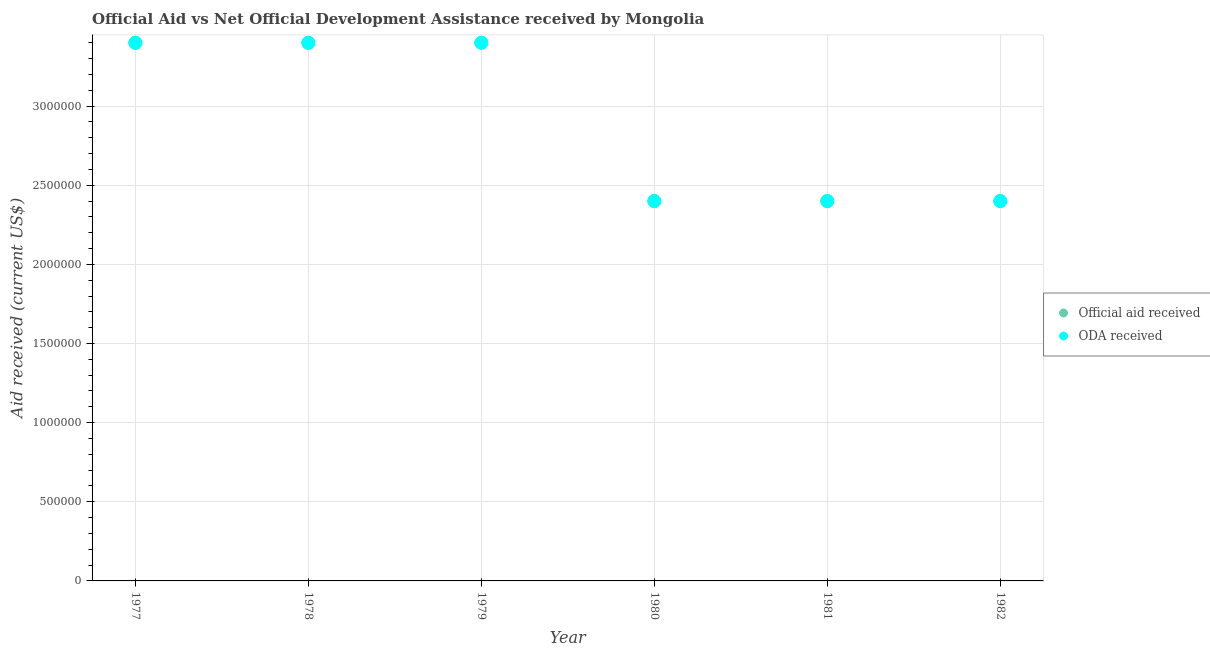How many different coloured dotlines are there?
Offer a very short reply. 2. What is the oda received in 1978?
Provide a succinct answer. 3.40e+06. Across all years, what is the maximum oda received?
Offer a very short reply. 3.40e+06. Across all years, what is the minimum oda received?
Provide a succinct answer. 2.40e+06. In which year was the oda received minimum?
Give a very brief answer. 1980. What is the total oda received in the graph?
Provide a short and direct response. 1.74e+07. What is the difference between the oda received in 1979 and that in 1982?
Provide a succinct answer. 1.00e+06. What is the average oda received per year?
Give a very brief answer. 2.90e+06. In the year 1978, what is the difference between the oda received and official aid received?
Provide a short and direct response. 0. In how many years, is the official aid received greater than 500000 US$?
Offer a terse response. 6. Is the difference between the oda received in 1980 and 1982 greater than the difference between the official aid received in 1980 and 1982?
Ensure brevity in your answer.  No. What is the difference between the highest and the second highest official aid received?
Make the answer very short. 0. What is the difference between the highest and the lowest official aid received?
Your answer should be very brief. 1.00e+06. Is the oda received strictly greater than the official aid received over the years?
Make the answer very short. No. Is the oda received strictly less than the official aid received over the years?
Provide a short and direct response. No. How many years are there in the graph?
Provide a succinct answer. 6. What is the difference between two consecutive major ticks on the Y-axis?
Offer a terse response. 5.00e+05. Where does the legend appear in the graph?
Provide a short and direct response. Center right. How many legend labels are there?
Provide a succinct answer. 2. How are the legend labels stacked?
Give a very brief answer. Vertical. What is the title of the graph?
Provide a succinct answer. Official Aid vs Net Official Development Assistance received by Mongolia . What is the label or title of the X-axis?
Your answer should be very brief. Year. What is the label or title of the Y-axis?
Provide a succinct answer. Aid received (current US$). What is the Aid received (current US$) in Official aid received in 1977?
Provide a short and direct response. 3.40e+06. What is the Aid received (current US$) in ODA received in 1977?
Offer a very short reply. 3.40e+06. What is the Aid received (current US$) of Official aid received in 1978?
Your answer should be compact. 3.40e+06. What is the Aid received (current US$) in ODA received in 1978?
Keep it short and to the point. 3.40e+06. What is the Aid received (current US$) in Official aid received in 1979?
Offer a very short reply. 3.40e+06. What is the Aid received (current US$) in ODA received in 1979?
Provide a short and direct response. 3.40e+06. What is the Aid received (current US$) in Official aid received in 1980?
Your answer should be compact. 2.40e+06. What is the Aid received (current US$) in ODA received in 1980?
Keep it short and to the point. 2.40e+06. What is the Aid received (current US$) in Official aid received in 1981?
Give a very brief answer. 2.40e+06. What is the Aid received (current US$) in ODA received in 1981?
Offer a terse response. 2.40e+06. What is the Aid received (current US$) in Official aid received in 1982?
Your answer should be very brief. 2.40e+06. What is the Aid received (current US$) in ODA received in 1982?
Keep it short and to the point. 2.40e+06. Across all years, what is the maximum Aid received (current US$) in Official aid received?
Offer a terse response. 3.40e+06. Across all years, what is the maximum Aid received (current US$) in ODA received?
Offer a very short reply. 3.40e+06. Across all years, what is the minimum Aid received (current US$) of Official aid received?
Offer a very short reply. 2.40e+06. Across all years, what is the minimum Aid received (current US$) of ODA received?
Offer a terse response. 2.40e+06. What is the total Aid received (current US$) in Official aid received in the graph?
Ensure brevity in your answer.  1.74e+07. What is the total Aid received (current US$) in ODA received in the graph?
Ensure brevity in your answer.  1.74e+07. What is the difference between the Aid received (current US$) of Official aid received in 1977 and that in 1978?
Your response must be concise. 0. What is the difference between the Aid received (current US$) in Official aid received in 1977 and that in 1979?
Give a very brief answer. 0. What is the difference between the Aid received (current US$) of ODA received in 1977 and that in 1979?
Offer a terse response. 0. What is the difference between the Aid received (current US$) of ODA received in 1977 and that in 1980?
Your response must be concise. 1.00e+06. What is the difference between the Aid received (current US$) in Official aid received in 1977 and that in 1981?
Ensure brevity in your answer.  1.00e+06. What is the difference between the Aid received (current US$) of ODA received in 1977 and that in 1981?
Give a very brief answer. 1.00e+06. What is the difference between the Aid received (current US$) of Official aid received in 1978 and that in 1979?
Provide a short and direct response. 0. What is the difference between the Aid received (current US$) of ODA received in 1978 and that in 1979?
Give a very brief answer. 0. What is the difference between the Aid received (current US$) in ODA received in 1978 and that in 1980?
Provide a short and direct response. 1.00e+06. What is the difference between the Aid received (current US$) of ODA received in 1978 and that in 1982?
Give a very brief answer. 1.00e+06. What is the difference between the Aid received (current US$) in Official aid received in 1979 and that in 1980?
Make the answer very short. 1.00e+06. What is the difference between the Aid received (current US$) of ODA received in 1979 and that in 1980?
Your response must be concise. 1.00e+06. What is the difference between the Aid received (current US$) in Official aid received in 1979 and that in 1981?
Your response must be concise. 1.00e+06. What is the difference between the Aid received (current US$) of ODA received in 1979 and that in 1982?
Your answer should be very brief. 1.00e+06. What is the difference between the Aid received (current US$) in Official aid received in 1980 and that in 1981?
Your response must be concise. 0. What is the difference between the Aid received (current US$) of ODA received in 1980 and that in 1982?
Make the answer very short. 0. What is the difference between the Aid received (current US$) in Official aid received in 1981 and that in 1982?
Your answer should be very brief. 0. What is the difference between the Aid received (current US$) in Official aid received in 1977 and the Aid received (current US$) in ODA received in 1978?
Keep it short and to the point. 0. What is the difference between the Aid received (current US$) of Official aid received in 1977 and the Aid received (current US$) of ODA received in 1979?
Make the answer very short. 0. What is the difference between the Aid received (current US$) of Official aid received in 1978 and the Aid received (current US$) of ODA received in 1979?
Your answer should be compact. 0. What is the difference between the Aid received (current US$) of Official aid received in 1978 and the Aid received (current US$) of ODA received in 1982?
Give a very brief answer. 1.00e+06. What is the difference between the Aid received (current US$) of Official aid received in 1979 and the Aid received (current US$) of ODA received in 1980?
Offer a terse response. 1.00e+06. What is the difference between the Aid received (current US$) in Official aid received in 1979 and the Aid received (current US$) in ODA received in 1981?
Provide a succinct answer. 1.00e+06. What is the difference between the Aid received (current US$) in Official aid received in 1980 and the Aid received (current US$) in ODA received in 1981?
Offer a very short reply. 0. What is the difference between the Aid received (current US$) of Official aid received in 1981 and the Aid received (current US$) of ODA received in 1982?
Provide a succinct answer. 0. What is the average Aid received (current US$) in Official aid received per year?
Provide a short and direct response. 2.90e+06. What is the average Aid received (current US$) of ODA received per year?
Give a very brief answer. 2.90e+06. In the year 1978, what is the difference between the Aid received (current US$) in Official aid received and Aid received (current US$) in ODA received?
Your answer should be compact. 0. In the year 1980, what is the difference between the Aid received (current US$) of Official aid received and Aid received (current US$) of ODA received?
Offer a very short reply. 0. In the year 1981, what is the difference between the Aid received (current US$) of Official aid received and Aid received (current US$) of ODA received?
Make the answer very short. 0. What is the ratio of the Aid received (current US$) in Official aid received in 1977 to that in 1978?
Ensure brevity in your answer.  1. What is the ratio of the Aid received (current US$) of Official aid received in 1977 to that in 1979?
Keep it short and to the point. 1. What is the ratio of the Aid received (current US$) in ODA received in 1977 to that in 1979?
Keep it short and to the point. 1. What is the ratio of the Aid received (current US$) of Official aid received in 1977 to that in 1980?
Offer a terse response. 1.42. What is the ratio of the Aid received (current US$) in ODA received in 1977 to that in 1980?
Your answer should be compact. 1.42. What is the ratio of the Aid received (current US$) of Official aid received in 1977 to that in 1981?
Your answer should be compact. 1.42. What is the ratio of the Aid received (current US$) of ODA received in 1977 to that in 1981?
Give a very brief answer. 1.42. What is the ratio of the Aid received (current US$) of Official aid received in 1977 to that in 1982?
Keep it short and to the point. 1.42. What is the ratio of the Aid received (current US$) in ODA received in 1977 to that in 1982?
Make the answer very short. 1.42. What is the ratio of the Aid received (current US$) in Official aid received in 1978 to that in 1979?
Offer a terse response. 1. What is the ratio of the Aid received (current US$) in Official aid received in 1978 to that in 1980?
Offer a terse response. 1.42. What is the ratio of the Aid received (current US$) of ODA received in 1978 to that in 1980?
Provide a short and direct response. 1.42. What is the ratio of the Aid received (current US$) of Official aid received in 1978 to that in 1981?
Give a very brief answer. 1.42. What is the ratio of the Aid received (current US$) of ODA received in 1978 to that in 1981?
Offer a very short reply. 1.42. What is the ratio of the Aid received (current US$) in Official aid received in 1978 to that in 1982?
Ensure brevity in your answer.  1.42. What is the ratio of the Aid received (current US$) in ODA received in 1978 to that in 1982?
Provide a succinct answer. 1.42. What is the ratio of the Aid received (current US$) in Official aid received in 1979 to that in 1980?
Your answer should be compact. 1.42. What is the ratio of the Aid received (current US$) of ODA received in 1979 to that in 1980?
Ensure brevity in your answer.  1.42. What is the ratio of the Aid received (current US$) in Official aid received in 1979 to that in 1981?
Offer a very short reply. 1.42. What is the ratio of the Aid received (current US$) in ODA received in 1979 to that in 1981?
Your answer should be compact. 1.42. What is the ratio of the Aid received (current US$) of Official aid received in 1979 to that in 1982?
Your response must be concise. 1.42. What is the ratio of the Aid received (current US$) of ODA received in 1979 to that in 1982?
Offer a very short reply. 1.42. What is the ratio of the Aid received (current US$) of Official aid received in 1980 to that in 1981?
Make the answer very short. 1. What is the ratio of the Aid received (current US$) in Official aid received in 1980 to that in 1982?
Your answer should be very brief. 1. What is the ratio of the Aid received (current US$) in ODA received in 1980 to that in 1982?
Give a very brief answer. 1. What is the ratio of the Aid received (current US$) in Official aid received in 1981 to that in 1982?
Your answer should be very brief. 1. What is the ratio of the Aid received (current US$) of ODA received in 1981 to that in 1982?
Give a very brief answer. 1. What is the difference between the highest and the second highest Aid received (current US$) in Official aid received?
Make the answer very short. 0. 